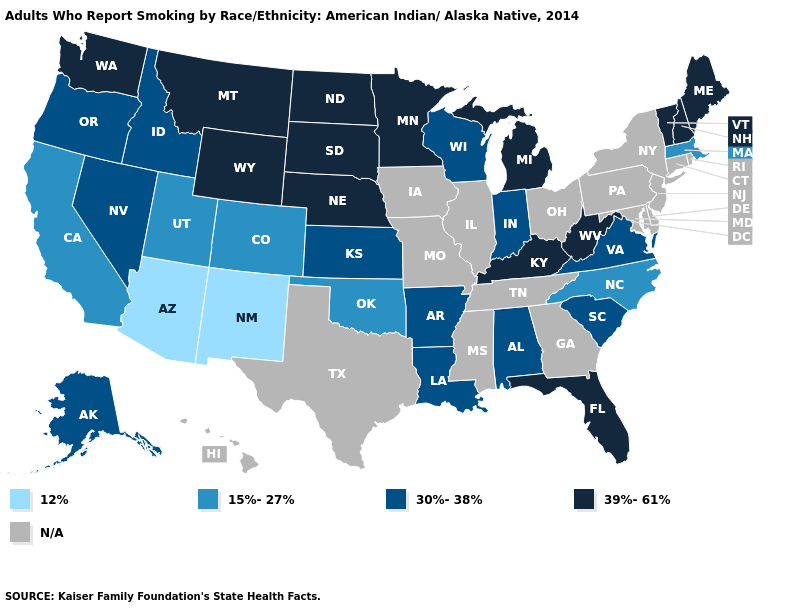What is the highest value in the USA?
Concise answer only. 39%-61%. Among the states that border North Dakota , which have the highest value?
Quick response, please. Minnesota, Montana, South Dakota. Name the states that have a value in the range N/A?
Concise answer only. Connecticut, Delaware, Georgia, Hawaii, Illinois, Iowa, Maryland, Mississippi, Missouri, New Jersey, New York, Ohio, Pennsylvania, Rhode Island, Tennessee, Texas. Among the states that border Oklahoma , does New Mexico have the lowest value?
Answer briefly. Yes. What is the value of Hawaii?
Short answer required. N/A. What is the lowest value in states that border Maryland?
Quick response, please. 30%-38%. Does Oklahoma have the lowest value in the South?
Concise answer only. Yes. Among the states that border Nevada , which have the highest value?
Keep it brief. Idaho, Oregon. What is the value of Arizona?
Quick response, please. 12%. Which states have the lowest value in the Northeast?
Concise answer only. Massachusetts. Is the legend a continuous bar?
Quick response, please. No. What is the value of Alaska?
Be succinct. 30%-38%. What is the value of South Carolina?
Answer briefly. 30%-38%. Does the first symbol in the legend represent the smallest category?
Quick response, please. Yes. 